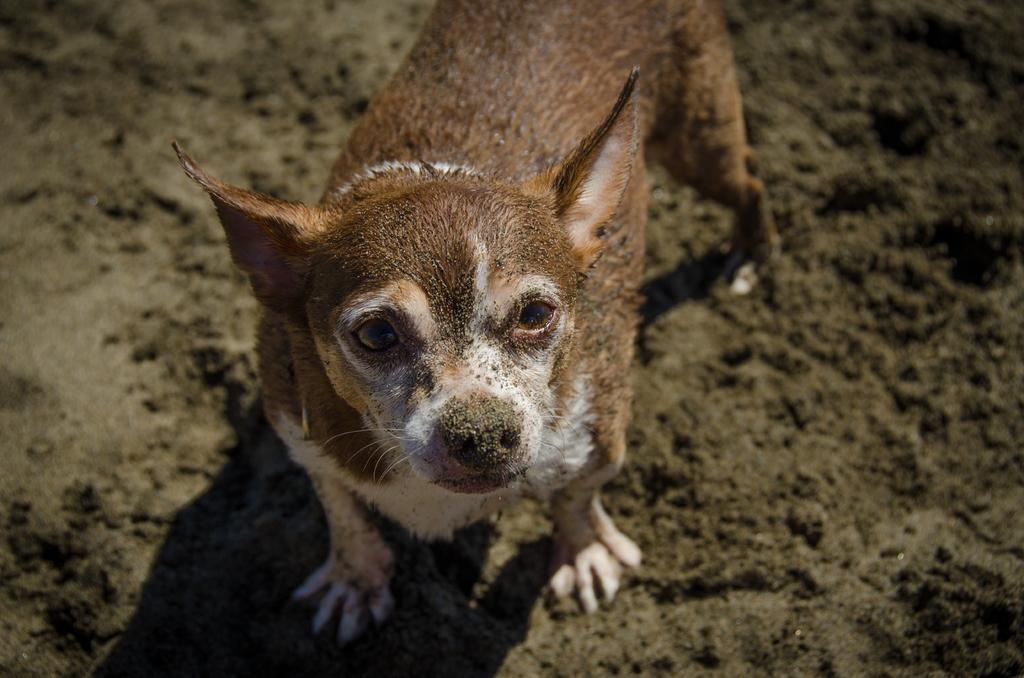What type of animal is in the image? There is a dog in the image. What is the dog doing in the image? The dog is standing. How many pigs are visible in the image? There are no pigs present in the image; it features a dog. What type of smoke can be seen coming from the dog's ears in the image? There is no smoke present in the image, and the dog's ears are not depicted as producing smoke. 